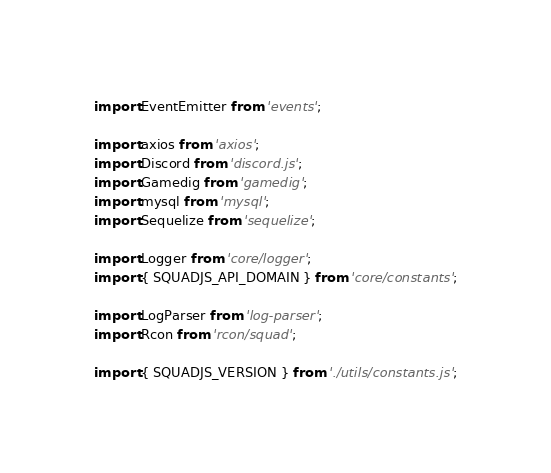<code> <loc_0><loc_0><loc_500><loc_500><_JavaScript_>import EventEmitter from 'events';

import axios from 'axios';
import Discord from 'discord.js';
import Gamedig from 'gamedig';
import mysql from 'mysql';
import Sequelize from 'sequelize';

import Logger from 'core/logger';
import { SQUADJS_API_DOMAIN } from 'core/constants';

import LogParser from 'log-parser';
import Rcon from 'rcon/squad';

import { SQUADJS_VERSION } from './utils/constants.js';</code> 